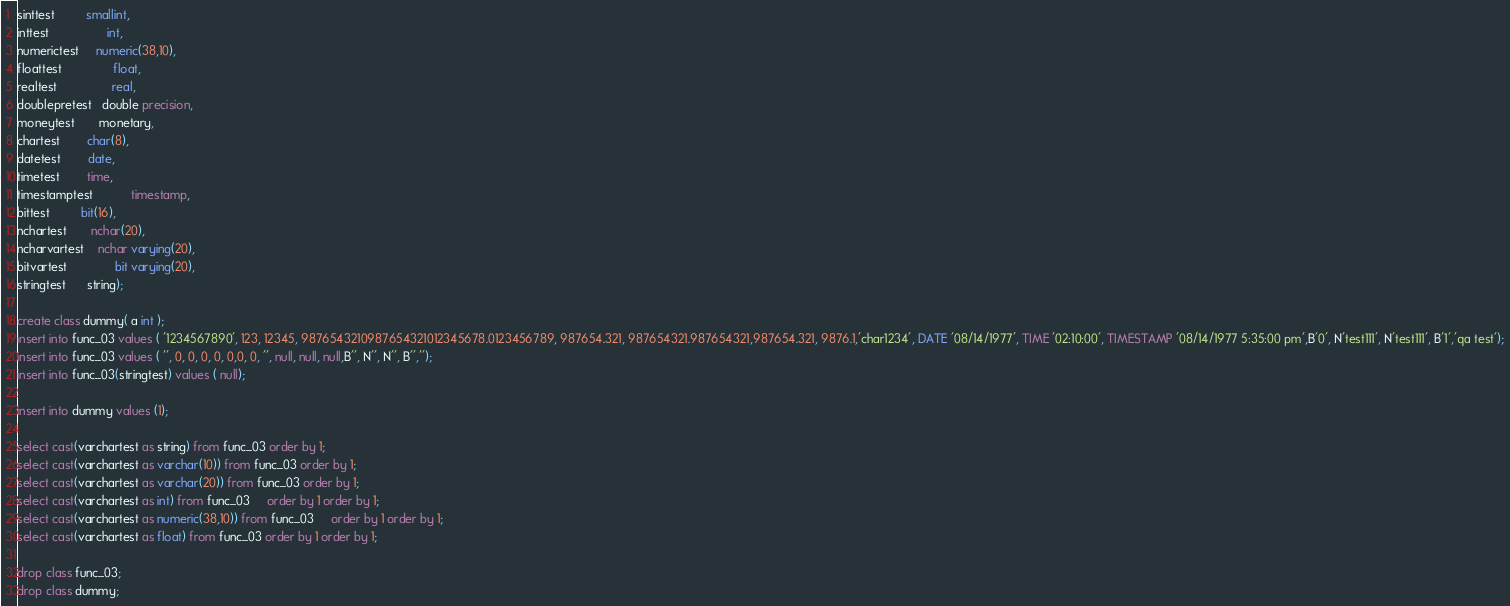Convert code to text. <code><loc_0><loc_0><loc_500><loc_500><_SQL_>sinttest         smallint,
inttest                 int,
numerictest     numeric(38,10),
floattest               float,
realtest                real,
doublepretest   double precision,
moneytest       monetary,
chartest        char(8),
datetest        date,
timetest        time,
timestamptest           timestamp,
bittest         bit(16),
nchartest       nchar(20),
ncharvartest    nchar varying(20),
bitvartest              bit varying(20),
stringtest      string);

create class dummy( a int );
insert into func_03 values ( '1234567890', 123, 12345, 9876543210987654321012345678.0123456789, 987654.321, 987654321.987654321,987654.321, 9876.1,'char1234', DATE '08/14/1977', TIME '02:10:00', TIMESTAMP '08/14/1977 5:35:00 pm',B'0', N'test111', N'test111', B'1','qa test');
insert into func_03 values ( '', 0, 0, 0, 0, 0,0, 0, '', null, null, null,B'', N'', N'', B'','');
insert into func_03(stringtest) values ( null);

insert into dummy values (1);

select cast(varchartest as string) from func_03 order by 1;	
select cast(varchartest as varchar(10)) from func_03 order by 1;	
select cast(varchartest as varchar(20)) from func_03 order by 1;	
select cast(varchartest as int) from func_03	 order by 1 order by 1;
select cast(varchartest as numeric(38,10)) from func_03	 order by 1 order by 1;
select cast(varchartest as float) from func_03 order by 1 order by 1;

drop class func_03;
drop class dummy;
</code> 